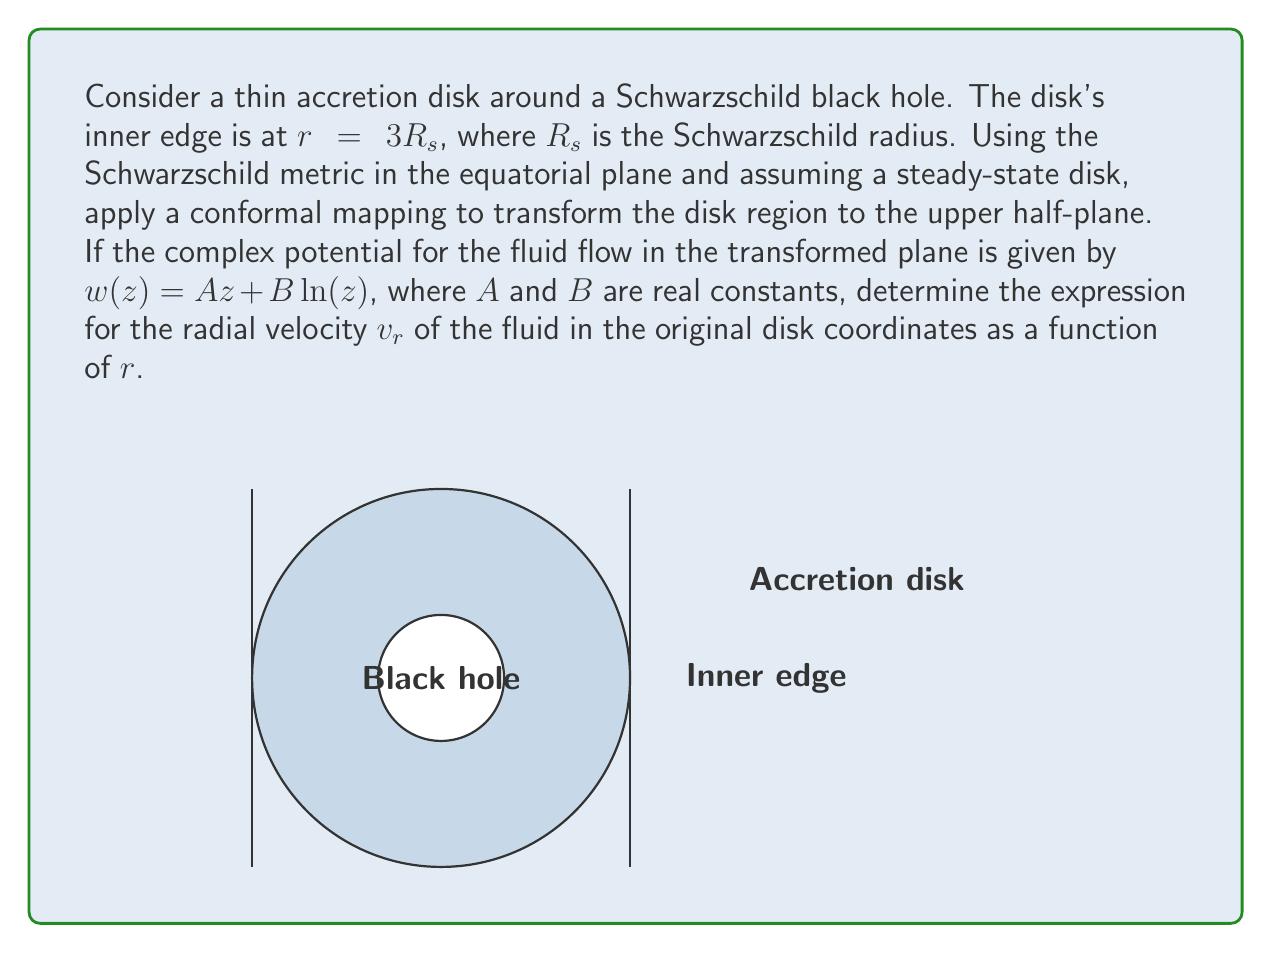Can you solve this math problem? Let's approach this step-by-step:

1) First, we need to apply a conformal mapping that transforms the disk region to the upper half-plane. A suitable mapping is:

   $$z = \frac{R_s}{2}\left(\frac{r}{R_s} + \frac{R_s}{r}\right)$$

   This maps the region $r > 3R_s$ to the positive real axis in the $z$-plane.

2) The inverse transformation is:

   $$r = R_s\sqrt{\frac{2z}{R_s} + 1}$$

3) In the transformed plane, we have the complex potential:

   $$w(z) = Az + B\ln(z)$$

4) The complex velocity in the $z$-plane is given by:

   $$\frac{dw}{dz} = A + \frac{B}{z}$$

5) To get the velocity in the original $r$-plane, we need to use the chain rule:

   $$\frac{dw}{dr} = \frac{dw}{dz} \cdot \frac{dz}{dr}$$

6) We can calculate $\frac{dz}{dr}$ from the transformation:

   $$\frac{dz}{dr} = \frac{R_s}{2}\left(\frac{1}{R_s} - \frac{R_s}{r^2}\right) = \frac{1}{2}\left(1 - \frac{R_s^2}{r^2}\right)$$

7) Now, we can express the radial velocity $v_r$ as:

   $$v_r = -\text{Re}\left(\frac{dw}{dr}\right) = -\text{Re}\left(\left(A + \frac{B}{z}\right) \cdot \frac{1}{2}\left(1 - \frac{R_s^2}{r^2}\right)\right)$$

8) Substituting the expression for $z$ in terms of $r$:

   $$v_r = -\frac{1}{2}\left(1 - \frac{R_s^2}{r^2}\right)\left(A + \frac{2B}{R_s}\cdot\frac{r}{r^2 + R_s^2}\right)$$

9) This can be simplified to:

   $$v_r = -\frac{1}{2}\left(A\left(1 - \frac{R_s^2}{r^2}\right) + \frac{2B}{R_s}\cdot\frac{r}{r^2 + R_s^2}\left(1 - \frac{R_s^2}{r^2}\right)\right)$$

This is the final expression for the radial velocity as a function of $r$.
Answer: $$v_r = -\frac{1}{2}\left(A\left(1 - \frac{R_s^2}{r^2}\right) + \frac{2B}{R_s}\cdot\frac{r}{r^2 + R_s^2}\left(1 - \frac{R_s^2}{r^2}\right)\right)$$ 